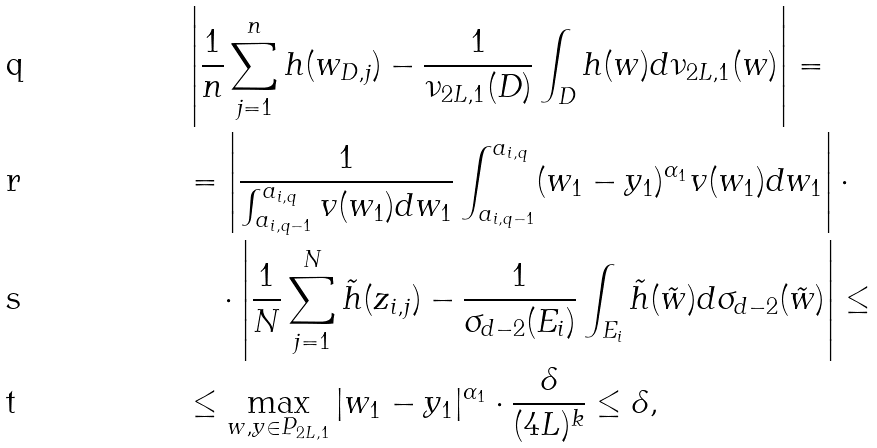<formula> <loc_0><loc_0><loc_500><loc_500>& \left | \frac { 1 } { n } \sum _ { j = 1 } ^ { n } h ( w _ { D , j } ) - \frac { 1 } { \nu _ { 2 L , 1 } ( D ) } \int _ { D } h ( w ) d \nu _ { 2 L , 1 } ( w ) \right | = \\ & = \left | \frac { 1 } { \int _ { a _ { i , q - 1 } } ^ { a _ { i , q } } v ( w _ { 1 } ) d w _ { 1 } } \int _ { a _ { i , q - 1 } } ^ { a _ { i , q } } ( w _ { 1 } - y _ { 1 } ) ^ { \alpha _ { 1 } } v ( w _ { 1 } ) d w _ { 1 } \right | \cdot \\ & \quad \cdot \left | \frac { 1 } { N } \sum _ { j = 1 } ^ { N } \tilde { h } ( z _ { i , j } ) - \frac { 1 } { \sigma _ { d - 2 } ( E _ { i } ) } \int _ { E _ { i } } \tilde { h } ( \tilde { w } ) d \sigma _ { d - 2 } ( \tilde { w } ) \right | \leq \\ & \leq \max _ { w , y \in P _ { 2 L , 1 } } | w _ { 1 } - y _ { 1 } | ^ { \alpha _ { 1 } } \cdot \frac { \delta } { ( 4 L ) ^ { k } } \leq \delta ,</formula> 